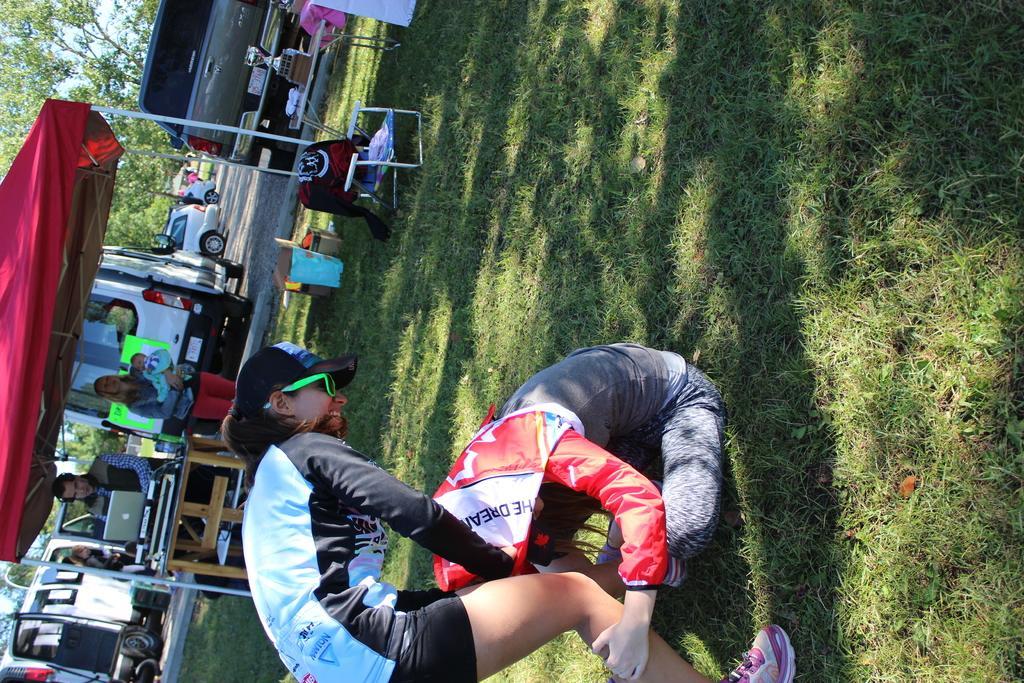Describe this image in one or two sentences. In the center of the image we can see two women. In that a woman is sitting on the grass. On the backside we can see some people standing under a tent. We can also see a person standing beside a table containing a laptop on it, a woman carrying a baby, some bags, a baby carrier and a table containing some objects which are placed on the ground. We can also see some trees, a group of vehicles and the sky. 